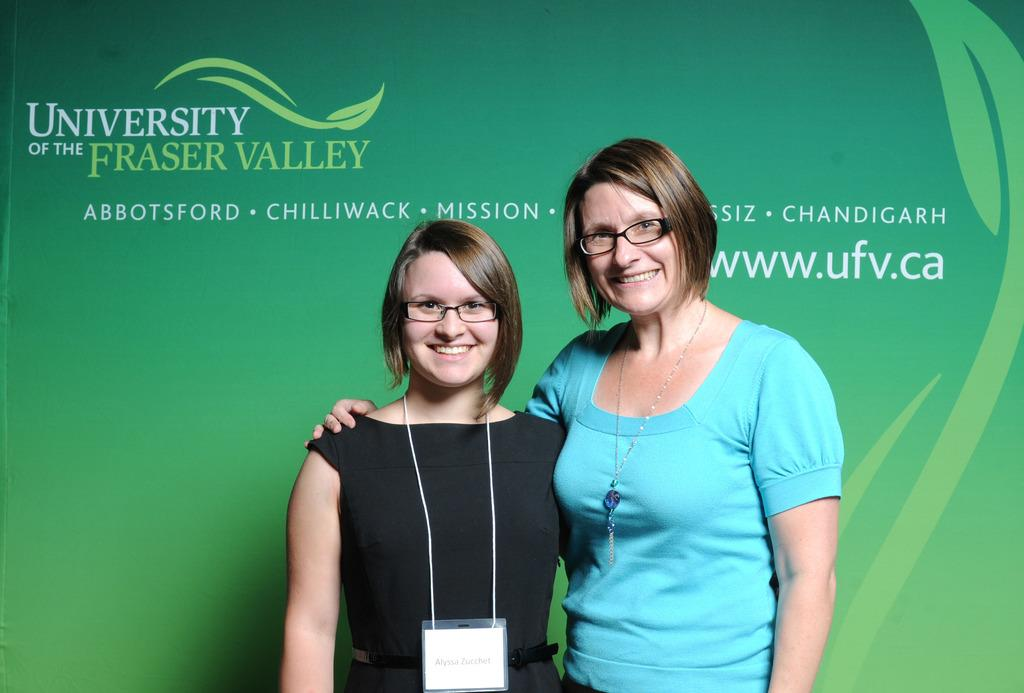How many women are in the image? There are two women in the image. What colors are the dresses worn by the women? The woman on the left is wearing a black dress, and the woman on the right is wearing a blue dress. What can be seen in the background of the image? There is a banner in the background of the image. What is the color of the banner? The banner is green in color. What type of parent is depicted with the women in the image? There is no parent depicted in the image; it features two women and a green banner in the background. How many ducks are visible in the image? There are no ducks present in the image. 